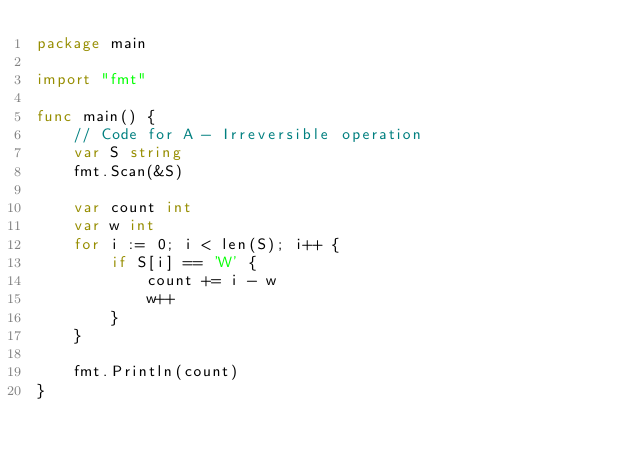<code> <loc_0><loc_0><loc_500><loc_500><_Go_>package main

import "fmt"

func main() {
	// Code for A - Irreversible operation
	var S string
	fmt.Scan(&S)

	var count int
	var w int
	for i := 0; i < len(S); i++ {
		if S[i] == 'W' {
			count += i - w
			w++
		}
	}

	fmt.Println(count)
}
</code> 